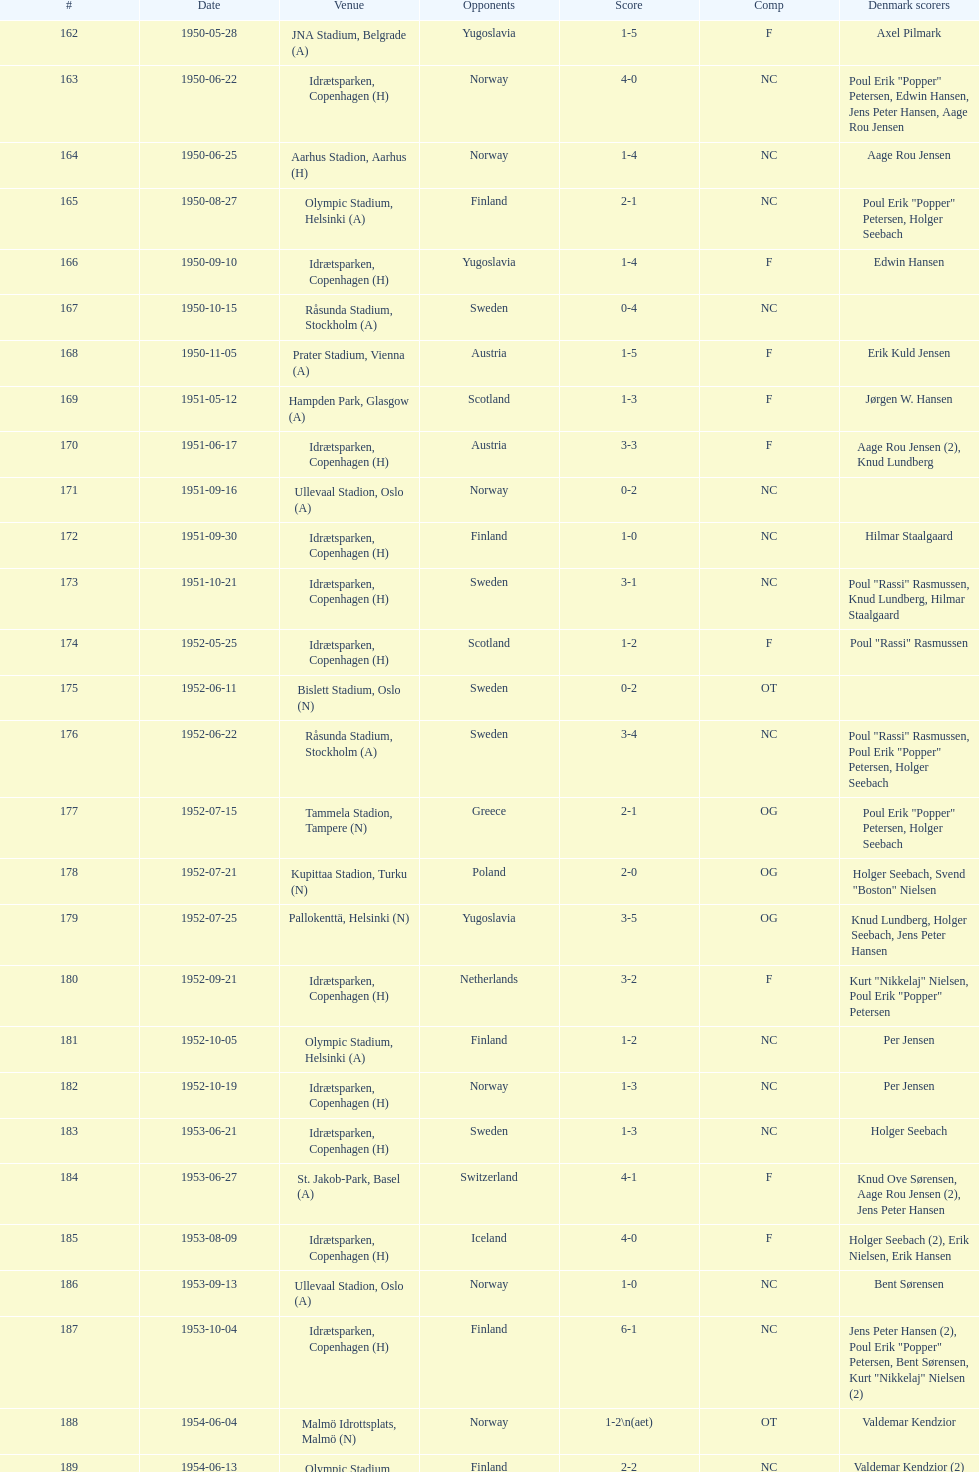In the "comp" column, what is the frequency of "nc" appearances? 32. 